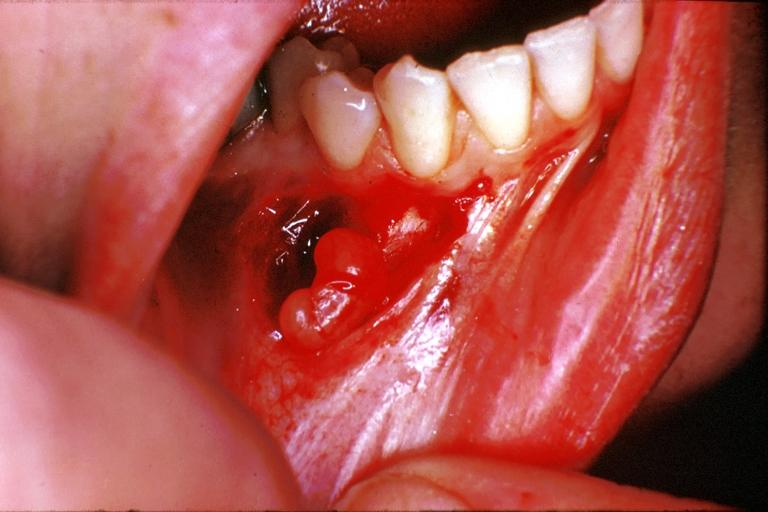s oral present?
Answer the question using a single word or phrase. Yes 